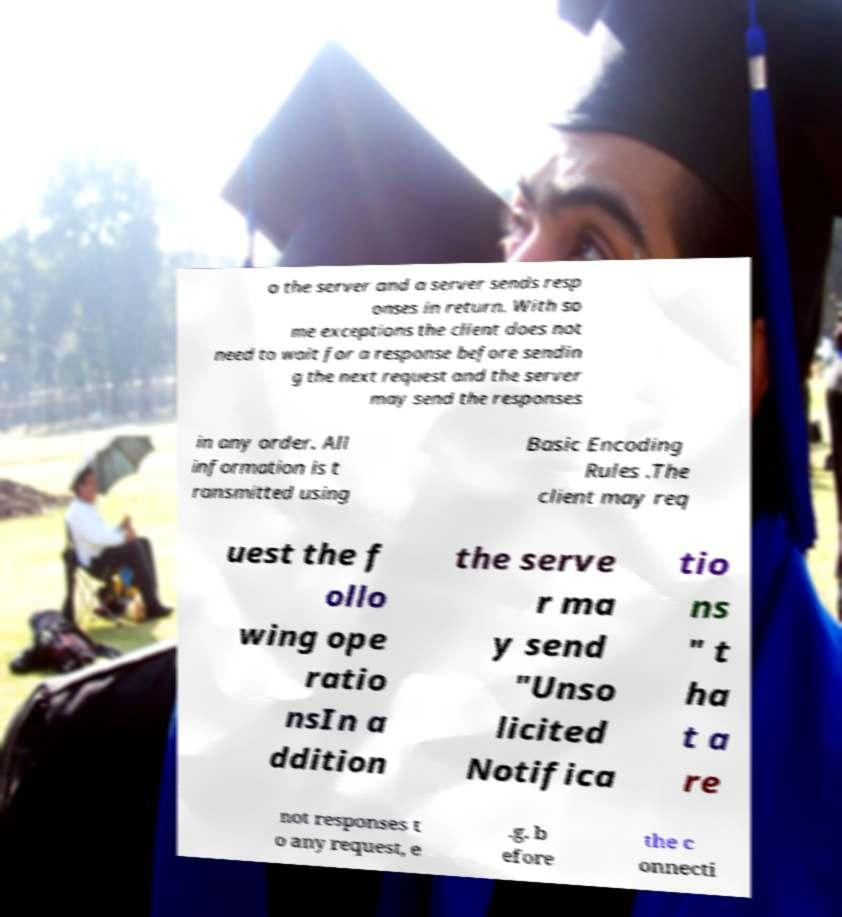Please read and relay the text visible in this image. What does it say? o the server and a server sends resp onses in return. With so me exceptions the client does not need to wait for a response before sendin g the next request and the server may send the responses in any order. All information is t ransmitted using Basic Encoding Rules .The client may req uest the f ollo wing ope ratio nsIn a ddition the serve r ma y send "Unso licited Notifica tio ns " t ha t a re not responses t o any request, e .g. b efore the c onnecti 